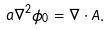Convert formula to latex. <formula><loc_0><loc_0><loc_500><loc_500>a \nabla ^ { 2 } \phi _ { 0 } = \nabla \cdot { A } .</formula> 